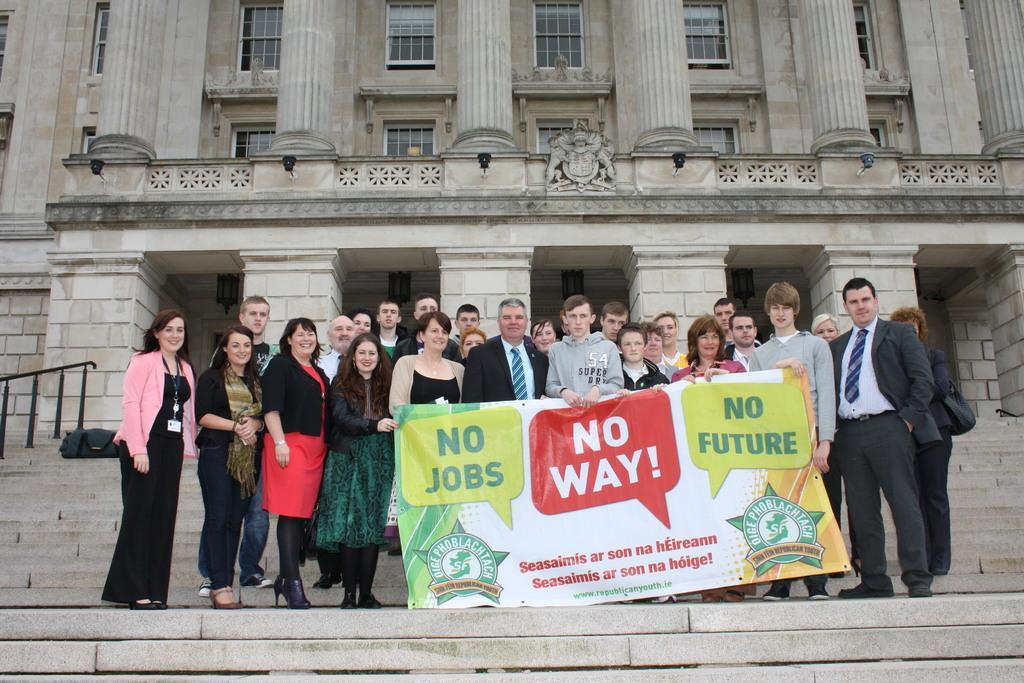How would you summarize this image in a sentence or two? In this image there are people standing. There is a banner. There are steps in the foreground. There is a building in the background. There are windows with the glasses. 